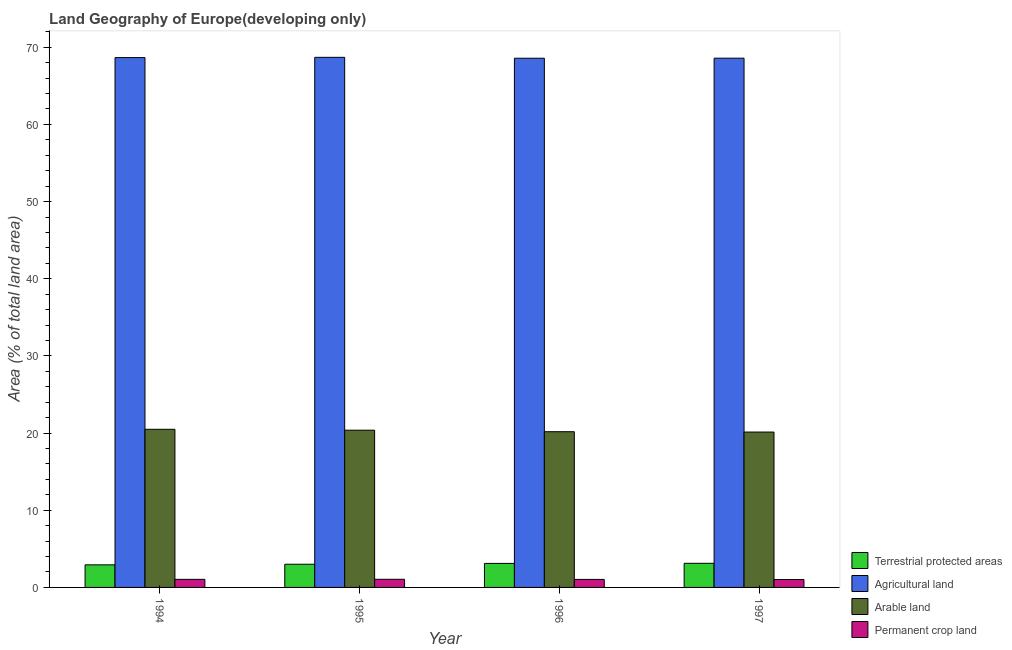How many different coloured bars are there?
Offer a very short reply. 4. How many groups of bars are there?
Keep it short and to the point. 4. In how many cases, is the number of bars for a given year not equal to the number of legend labels?
Offer a terse response. 0. What is the percentage of area under agricultural land in 1997?
Offer a terse response. 68.58. Across all years, what is the maximum percentage of area under arable land?
Ensure brevity in your answer.  20.49. Across all years, what is the minimum percentage of area under arable land?
Your answer should be compact. 20.13. In which year was the percentage of land under terrestrial protection minimum?
Your answer should be compact. 1994. What is the total percentage of land under terrestrial protection in the graph?
Keep it short and to the point. 12.17. What is the difference between the percentage of land under terrestrial protection in 1995 and that in 1997?
Your response must be concise. -0.12. What is the difference between the percentage of land under terrestrial protection in 1995 and the percentage of area under permanent crop land in 1997?
Give a very brief answer. -0.12. What is the average percentage of area under agricultural land per year?
Offer a terse response. 68.63. In the year 1997, what is the difference between the percentage of land under terrestrial protection and percentage of area under agricultural land?
Offer a terse response. 0. In how many years, is the percentage of area under arable land greater than 12 %?
Provide a succinct answer. 4. What is the ratio of the percentage of area under permanent crop land in 1996 to that in 1997?
Your answer should be compact. 1.01. Is the percentage of land under terrestrial protection in 1994 less than that in 1997?
Your response must be concise. Yes. What is the difference between the highest and the second highest percentage of land under terrestrial protection?
Offer a very short reply. 0.01. What is the difference between the highest and the lowest percentage of area under agricultural land?
Keep it short and to the point. 0.12. In how many years, is the percentage of area under agricultural land greater than the average percentage of area under agricultural land taken over all years?
Provide a short and direct response. 2. Is the sum of the percentage of area under permanent crop land in 1994 and 1997 greater than the maximum percentage of area under arable land across all years?
Your response must be concise. Yes. What does the 4th bar from the left in 1995 represents?
Provide a short and direct response. Permanent crop land. What does the 4th bar from the right in 1995 represents?
Make the answer very short. Terrestrial protected areas. Are all the bars in the graph horizontal?
Your answer should be very brief. No. What is the difference between two consecutive major ticks on the Y-axis?
Make the answer very short. 10. Does the graph contain any zero values?
Your response must be concise. No. Where does the legend appear in the graph?
Provide a succinct answer. Bottom right. How many legend labels are there?
Your answer should be compact. 4. How are the legend labels stacked?
Your answer should be compact. Vertical. What is the title of the graph?
Your answer should be compact. Land Geography of Europe(developing only). What is the label or title of the Y-axis?
Your response must be concise. Area (% of total land area). What is the Area (% of total land area) of Terrestrial protected areas in 1994?
Provide a succinct answer. 2.93. What is the Area (% of total land area) in Agricultural land in 1994?
Your answer should be compact. 68.66. What is the Area (% of total land area) of Arable land in 1994?
Your answer should be compact. 20.49. What is the Area (% of total land area) of Permanent crop land in 1994?
Offer a very short reply. 1.05. What is the Area (% of total land area) in Terrestrial protected areas in 1995?
Offer a very short reply. 3. What is the Area (% of total land area) in Agricultural land in 1995?
Provide a short and direct response. 68.69. What is the Area (% of total land area) in Arable land in 1995?
Give a very brief answer. 20.37. What is the Area (% of total land area) in Permanent crop land in 1995?
Your answer should be very brief. 1.05. What is the Area (% of total land area) of Terrestrial protected areas in 1996?
Your answer should be very brief. 3.11. What is the Area (% of total land area) of Agricultural land in 1996?
Ensure brevity in your answer.  68.58. What is the Area (% of total land area) in Arable land in 1996?
Your answer should be very brief. 20.18. What is the Area (% of total land area) of Permanent crop land in 1996?
Ensure brevity in your answer.  1.04. What is the Area (% of total land area) of Terrestrial protected areas in 1997?
Provide a succinct answer. 3.13. What is the Area (% of total land area) of Agricultural land in 1997?
Your response must be concise. 68.58. What is the Area (% of total land area) in Arable land in 1997?
Ensure brevity in your answer.  20.13. What is the Area (% of total land area) in Permanent crop land in 1997?
Make the answer very short. 1.03. Across all years, what is the maximum Area (% of total land area) in Terrestrial protected areas?
Offer a terse response. 3.13. Across all years, what is the maximum Area (% of total land area) in Agricultural land?
Your response must be concise. 68.69. Across all years, what is the maximum Area (% of total land area) of Arable land?
Offer a terse response. 20.49. Across all years, what is the maximum Area (% of total land area) in Permanent crop land?
Make the answer very short. 1.05. Across all years, what is the minimum Area (% of total land area) in Terrestrial protected areas?
Keep it short and to the point. 2.93. Across all years, what is the minimum Area (% of total land area) of Agricultural land?
Provide a short and direct response. 68.58. Across all years, what is the minimum Area (% of total land area) in Arable land?
Offer a very short reply. 20.13. Across all years, what is the minimum Area (% of total land area) of Permanent crop land?
Keep it short and to the point. 1.03. What is the total Area (% of total land area) of Terrestrial protected areas in the graph?
Give a very brief answer. 12.17. What is the total Area (% of total land area) in Agricultural land in the graph?
Give a very brief answer. 274.5. What is the total Area (% of total land area) of Arable land in the graph?
Your response must be concise. 81.18. What is the total Area (% of total land area) of Permanent crop land in the graph?
Offer a terse response. 4.17. What is the difference between the Area (% of total land area) in Terrestrial protected areas in 1994 and that in 1995?
Provide a succinct answer. -0.08. What is the difference between the Area (% of total land area) of Agricultural land in 1994 and that in 1995?
Keep it short and to the point. -0.04. What is the difference between the Area (% of total land area) of Arable land in 1994 and that in 1995?
Provide a succinct answer. 0.12. What is the difference between the Area (% of total land area) in Permanent crop land in 1994 and that in 1995?
Keep it short and to the point. -0.01. What is the difference between the Area (% of total land area) in Terrestrial protected areas in 1994 and that in 1996?
Make the answer very short. -0.18. What is the difference between the Area (% of total land area) of Agricultural land in 1994 and that in 1996?
Your answer should be compact. 0.08. What is the difference between the Area (% of total land area) of Arable land in 1994 and that in 1996?
Offer a terse response. 0.31. What is the difference between the Area (% of total land area) of Permanent crop land in 1994 and that in 1996?
Give a very brief answer. 0.01. What is the difference between the Area (% of total land area) of Terrestrial protected areas in 1994 and that in 1997?
Your answer should be very brief. -0.2. What is the difference between the Area (% of total land area) of Agricultural land in 1994 and that in 1997?
Provide a succinct answer. 0.08. What is the difference between the Area (% of total land area) in Arable land in 1994 and that in 1997?
Ensure brevity in your answer.  0.36. What is the difference between the Area (% of total land area) in Permanent crop land in 1994 and that in 1997?
Keep it short and to the point. 0.02. What is the difference between the Area (% of total land area) of Terrestrial protected areas in 1995 and that in 1996?
Offer a terse response. -0.11. What is the difference between the Area (% of total land area) of Agricultural land in 1995 and that in 1996?
Give a very brief answer. 0.12. What is the difference between the Area (% of total land area) in Arable land in 1995 and that in 1996?
Make the answer very short. 0.2. What is the difference between the Area (% of total land area) in Permanent crop land in 1995 and that in 1996?
Make the answer very short. 0.02. What is the difference between the Area (% of total land area) in Terrestrial protected areas in 1995 and that in 1997?
Make the answer very short. -0.12. What is the difference between the Area (% of total land area) in Agricultural land in 1995 and that in 1997?
Make the answer very short. 0.11. What is the difference between the Area (% of total land area) of Arable land in 1995 and that in 1997?
Give a very brief answer. 0.24. What is the difference between the Area (% of total land area) of Permanent crop land in 1995 and that in 1997?
Your response must be concise. 0.03. What is the difference between the Area (% of total land area) of Terrestrial protected areas in 1996 and that in 1997?
Keep it short and to the point. -0.01. What is the difference between the Area (% of total land area) of Agricultural land in 1996 and that in 1997?
Provide a short and direct response. -0.01. What is the difference between the Area (% of total land area) in Arable land in 1996 and that in 1997?
Your response must be concise. 0.04. What is the difference between the Area (% of total land area) of Permanent crop land in 1996 and that in 1997?
Provide a succinct answer. 0.01. What is the difference between the Area (% of total land area) in Terrestrial protected areas in 1994 and the Area (% of total land area) in Agricultural land in 1995?
Provide a succinct answer. -65.76. What is the difference between the Area (% of total land area) of Terrestrial protected areas in 1994 and the Area (% of total land area) of Arable land in 1995?
Offer a very short reply. -17.45. What is the difference between the Area (% of total land area) in Terrestrial protected areas in 1994 and the Area (% of total land area) in Permanent crop land in 1995?
Give a very brief answer. 1.87. What is the difference between the Area (% of total land area) of Agricultural land in 1994 and the Area (% of total land area) of Arable land in 1995?
Offer a very short reply. 48.28. What is the difference between the Area (% of total land area) in Agricultural land in 1994 and the Area (% of total land area) in Permanent crop land in 1995?
Your response must be concise. 67.6. What is the difference between the Area (% of total land area) in Arable land in 1994 and the Area (% of total land area) in Permanent crop land in 1995?
Your answer should be very brief. 19.44. What is the difference between the Area (% of total land area) in Terrestrial protected areas in 1994 and the Area (% of total land area) in Agricultural land in 1996?
Offer a very short reply. -65.65. What is the difference between the Area (% of total land area) of Terrestrial protected areas in 1994 and the Area (% of total land area) of Arable land in 1996?
Offer a terse response. -17.25. What is the difference between the Area (% of total land area) of Terrestrial protected areas in 1994 and the Area (% of total land area) of Permanent crop land in 1996?
Offer a terse response. 1.89. What is the difference between the Area (% of total land area) of Agricultural land in 1994 and the Area (% of total land area) of Arable land in 1996?
Your answer should be very brief. 48.48. What is the difference between the Area (% of total land area) in Agricultural land in 1994 and the Area (% of total land area) in Permanent crop land in 1996?
Ensure brevity in your answer.  67.62. What is the difference between the Area (% of total land area) of Arable land in 1994 and the Area (% of total land area) of Permanent crop land in 1996?
Provide a succinct answer. 19.45. What is the difference between the Area (% of total land area) in Terrestrial protected areas in 1994 and the Area (% of total land area) in Agricultural land in 1997?
Provide a short and direct response. -65.65. What is the difference between the Area (% of total land area) in Terrestrial protected areas in 1994 and the Area (% of total land area) in Arable land in 1997?
Your answer should be compact. -17.21. What is the difference between the Area (% of total land area) in Terrestrial protected areas in 1994 and the Area (% of total land area) in Permanent crop land in 1997?
Your response must be concise. 1.9. What is the difference between the Area (% of total land area) in Agricultural land in 1994 and the Area (% of total land area) in Arable land in 1997?
Your answer should be compact. 48.52. What is the difference between the Area (% of total land area) in Agricultural land in 1994 and the Area (% of total land area) in Permanent crop land in 1997?
Offer a terse response. 67.63. What is the difference between the Area (% of total land area) in Arable land in 1994 and the Area (% of total land area) in Permanent crop land in 1997?
Provide a short and direct response. 19.46. What is the difference between the Area (% of total land area) of Terrestrial protected areas in 1995 and the Area (% of total land area) of Agricultural land in 1996?
Offer a very short reply. -65.57. What is the difference between the Area (% of total land area) in Terrestrial protected areas in 1995 and the Area (% of total land area) in Arable land in 1996?
Ensure brevity in your answer.  -17.17. What is the difference between the Area (% of total land area) of Terrestrial protected areas in 1995 and the Area (% of total land area) of Permanent crop land in 1996?
Ensure brevity in your answer.  1.97. What is the difference between the Area (% of total land area) in Agricultural land in 1995 and the Area (% of total land area) in Arable land in 1996?
Make the answer very short. 48.51. What is the difference between the Area (% of total land area) of Agricultural land in 1995 and the Area (% of total land area) of Permanent crop land in 1996?
Offer a very short reply. 67.65. What is the difference between the Area (% of total land area) in Arable land in 1995 and the Area (% of total land area) in Permanent crop land in 1996?
Provide a short and direct response. 19.34. What is the difference between the Area (% of total land area) in Terrestrial protected areas in 1995 and the Area (% of total land area) in Agricultural land in 1997?
Your answer should be very brief. -65.58. What is the difference between the Area (% of total land area) in Terrestrial protected areas in 1995 and the Area (% of total land area) in Arable land in 1997?
Keep it short and to the point. -17.13. What is the difference between the Area (% of total land area) in Terrestrial protected areas in 1995 and the Area (% of total land area) in Permanent crop land in 1997?
Offer a very short reply. 1.98. What is the difference between the Area (% of total land area) in Agricultural land in 1995 and the Area (% of total land area) in Arable land in 1997?
Keep it short and to the point. 48.56. What is the difference between the Area (% of total land area) of Agricultural land in 1995 and the Area (% of total land area) of Permanent crop land in 1997?
Make the answer very short. 67.67. What is the difference between the Area (% of total land area) in Arable land in 1995 and the Area (% of total land area) in Permanent crop land in 1997?
Your response must be concise. 19.35. What is the difference between the Area (% of total land area) in Terrestrial protected areas in 1996 and the Area (% of total land area) in Agricultural land in 1997?
Offer a terse response. -65.47. What is the difference between the Area (% of total land area) of Terrestrial protected areas in 1996 and the Area (% of total land area) of Arable land in 1997?
Your answer should be compact. -17.02. What is the difference between the Area (% of total land area) in Terrestrial protected areas in 1996 and the Area (% of total land area) in Permanent crop land in 1997?
Your response must be concise. 2.09. What is the difference between the Area (% of total land area) in Agricultural land in 1996 and the Area (% of total land area) in Arable land in 1997?
Make the answer very short. 48.44. What is the difference between the Area (% of total land area) of Agricultural land in 1996 and the Area (% of total land area) of Permanent crop land in 1997?
Your response must be concise. 67.55. What is the difference between the Area (% of total land area) of Arable land in 1996 and the Area (% of total land area) of Permanent crop land in 1997?
Provide a succinct answer. 19.15. What is the average Area (% of total land area) in Terrestrial protected areas per year?
Provide a succinct answer. 3.04. What is the average Area (% of total land area) of Agricultural land per year?
Your answer should be compact. 68.63. What is the average Area (% of total land area) of Arable land per year?
Keep it short and to the point. 20.29. What is the average Area (% of total land area) in Permanent crop land per year?
Give a very brief answer. 1.04. In the year 1994, what is the difference between the Area (% of total land area) in Terrestrial protected areas and Area (% of total land area) in Agricultural land?
Offer a very short reply. -65.73. In the year 1994, what is the difference between the Area (% of total land area) in Terrestrial protected areas and Area (% of total land area) in Arable land?
Give a very brief answer. -17.56. In the year 1994, what is the difference between the Area (% of total land area) in Terrestrial protected areas and Area (% of total land area) in Permanent crop land?
Your answer should be compact. 1.88. In the year 1994, what is the difference between the Area (% of total land area) in Agricultural land and Area (% of total land area) in Arable land?
Provide a succinct answer. 48.17. In the year 1994, what is the difference between the Area (% of total land area) of Agricultural land and Area (% of total land area) of Permanent crop land?
Ensure brevity in your answer.  67.61. In the year 1994, what is the difference between the Area (% of total land area) of Arable land and Area (% of total land area) of Permanent crop land?
Offer a very short reply. 19.44. In the year 1995, what is the difference between the Area (% of total land area) of Terrestrial protected areas and Area (% of total land area) of Agricultural land?
Provide a succinct answer. -65.69. In the year 1995, what is the difference between the Area (% of total land area) in Terrestrial protected areas and Area (% of total land area) in Arable land?
Ensure brevity in your answer.  -17.37. In the year 1995, what is the difference between the Area (% of total land area) of Terrestrial protected areas and Area (% of total land area) of Permanent crop land?
Offer a very short reply. 1.95. In the year 1995, what is the difference between the Area (% of total land area) in Agricultural land and Area (% of total land area) in Arable land?
Your answer should be very brief. 48.32. In the year 1995, what is the difference between the Area (% of total land area) of Agricultural land and Area (% of total land area) of Permanent crop land?
Ensure brevity in your answer.  67.64. In the year 1995, what is the difference between the Area (% of total land area) of Arable land and Area (% of total land area) of Permanent crop land?
Offer a terse response. 19.32. In the year 1996, what is the difference between the Area (% of total land area) of Terrestrial protected areas and Area (% of total land area) of Agricultural land?
Offer a terse response. -65.46. In the year 1996, what is the difference between the Area (% of total land area) of Terrestrial protected areas and Area (% of total land area) of Arable land?
Give a very brief answer. -17.07. In the year 1996, what is the difference between the Area (% of total land area) of Terrestrial protected areas and Area (% of total land area) of Permanent crop land?
Keep it short and to the point. 2.07. In the year 1996, what is the difference between the Area (% of total land area) of Agricultural land and Area (% of total land area) of Arable land?
Keep it short and to the point. 48.4. In the year 1996, what is the difference between the Area (% of total land area) of Agricultural land and Area (% of total land area) of Permanent crop land?
Make the answer very short. 67.54. In the year 1996, what is the difference between the Area (% of total land area) of Arable land and Area (% of total land area) of Permanent crop land?
Your response must be concise. 19.14. In the year 1997, what is the difference between the Area (% of total land area) in Terrestrial protected areas and Area (% of total land area) in Agricultural land?
Provide a succinct answer. -65.46. In the year 1997, what is the difference between the Area (% of total land area) of Terrestrial protected areas and Area (% of total land area) of Arable land?
Ensure brevity in your answer.  -17.01. In the year 1997, what is the difference between the Area (% of total land area) of Terrestrial protected areas and Area (% of total land area) of Permanent crop land?
Ensure brevity in your answer.  2.1. In the year 1997, what is the difference between the Area (% of total land area) of Agricultural land and Area (% of total land area) of Arable land?
Provide a succinct answer. 48.45. In the year 1997, what is the difference between the Area (% of total land area) in Agricultural land and Area (% of total land area) in Permanent crop land?
Provide a succinct answer. 67.55. In the year 1997, what is the difference between the Area (% of total land area) of Arable land and Area (% of total land area) of Permanent crop land?
Offer a very short reply. 19.11. What is the ratio of the Area (% of total land area) in Terrestrial protected areas in 1994 to that in 1995?
Make the answer very short. 0.97. What is the ratio of the Area (% of total land area) of Agricultural land in 1994 to that in 1995?
Your answer should be compact. 1. What is the ratio of the Area (% of total land area) of Arable land in 1994 to that in 1995?
Keep it short and to the point. 1.01. What is the ratio of the Area (% of total land area) of Terrestrial protected areas in 1994 to that in 1996?
Give a very brief answer. 0.94. What is the ratio of the Area (% of total land area) of Arable land in 1994 to that in 1996?
Provide a succinct answer. 1.02. What is the ratio of the Area (% of total land area) in Permanent crop land in 1994 to that in 1996?
Offer a terse response. 1.01. What is the ratio of the Area (% of total land area) of Terrestrial protected areas in 1994 to that in 1997?
Keep it short and to the point. 0.94. What is the ratio of the Area (% of total land area) of Agricultural land in 1994 to that in 1997?
Your response must be concise. 1. What is the ratio of the Area (% of total land area) in Arable land in 1994 to that in 1997?
Give a very brief answer. 1.02. What is the ratio of the Area (% of total land area) in Permanent crop land in 1994 to that in 1997?
Keep it short and to the point. 1.02. What is the ratio of the Area (% of total land area) in Terrestrial protected areas in 1995 to that in 1996?
Offer a very short reply. 0.97. What is the ratio of the Area (% of total land area) in Agricultural land in 1995 to that in 1996?
Make the answer very short. 1. What is the ratio of the Area (% of total land area) in Arable land in 1995 to that in 1996?
Keep it short and to the point. 1.01. What is the ratio of the Area (% of total land area) in Permanent crop land in 1995 to that in 1996?
Your answer should be very brief. 1.01. What is the ratio of the Area (% of total land area) in Agricultural land in 1995 to that in 1997?
Provide a short and direct response. 1. What is the ratio of the Area (% of total land area) of Arable land in 1995 to that in 1997?
Provide a short and direct response. 1.01. What is the ratio of the Area (% of total land area) of Permanent crop land in 1995 to that in 1997?
Ensure brevity in your answer.  1.03. What is the ratio of the Area (% of total land area) of Arable land in 1996 to that in 1997?
Keep it short and to the point. 1. What is the ratio of the Area (% of total land area) of Permanent crop land in 1996 to that in 1997?
Offer a terse response. 1.01. What is the difference between the highest and the second highest Area (% of total land area) in Terrestrial protected areas?
Offer a terse response. 0.01. What is the difference between the highest and the second highest Area (% of total land area) in Agricultural land?
Provide a short and direct response. 0.04. What is the difference between the highest and the second highest Area (% of total land area) in Arable land?
Your response must be concise. 0.12. What is the difference between the highest and the second highest Area (% of total land area) in Permanent crop land?
Make the answer very short. 0.01. What is the difference between the highest and the lowest Area (% of total land area) in Terrestrial protected areas?
Provide a succinct answer. 0.2. What is the difference between the highest and the lowest Area (% of total land area) of Agricultural land?
Your answer should be compact. 0.12. What is the difference between the highest and the lowest Area (% of total land area) in Arable land?
Offer a very short reply. 0.36. What is the difference between the highest and the lowest Area (% of total land area) in Permanent crop land?
Your answer should be compact. 0.03. 